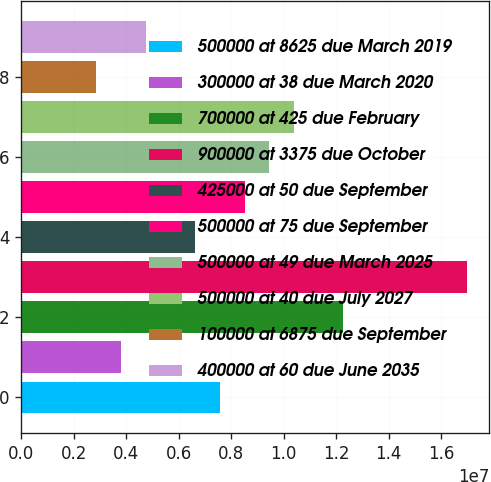Convert chart to OTSL. <chart><loc_0><loc_0><loc_500><loc_500><bar_chart><fcel>500000 at 8625 due March 2019<fcel>300000 at 38 due March 2020<fcel>700000 at 425 due February<fcel>900000 at 3375 due October<fcel>425000 at 50 due September<fcel>500000 at 75 due September<fcel>500000 at 49 due March 2025<fcel>500000 at 40 due July 2027<fcel>100000 at 6875 due September<fcel>400000 at 60 due June 2035<nl><fcel>7.56443e+06<fcel>3.79059e+06<fcel>1.22817e+07<fcel>1.6999e+07<fcel>6.62097e+06<fcel>8.50789e+06<fcel>9.45135e+06<fcel>1.03948e+07<fcel>2.84713e+06<fcel>4.73405e+06<nl></chart> 